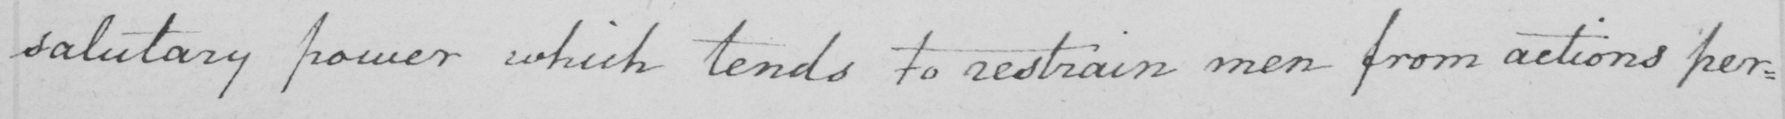What text is written in this handwritten line? salutary power which tends to restrain men from actions per : 